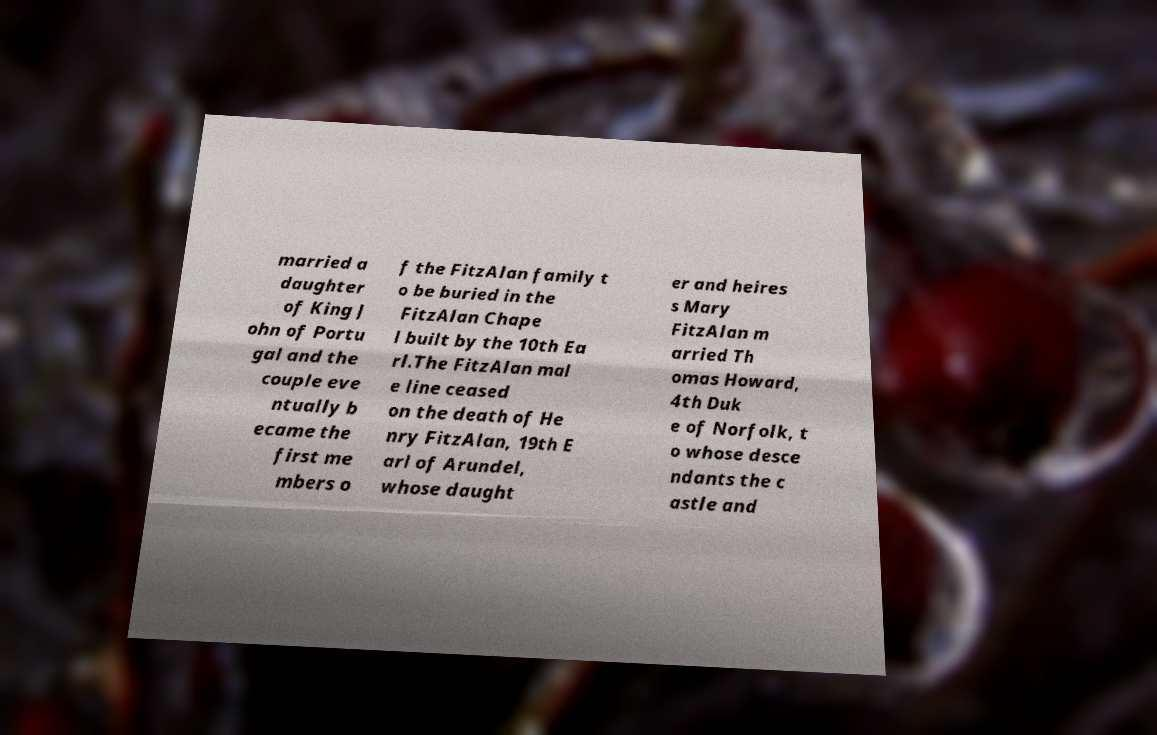What messages or text are displayed in this image? I need them in a readable, typed format. married a daughter of King J ohn of Portu gal and the couple eve ntually b ecame the first me mbers o f the FitzAlan family t o be buried in the FitzAlan Chape l built by the 10th Ea rl.The FitzAlan mal e line ceased on the death of He nry FitzAlan, 19th E arl of Arundel, whose daught er and heires s Mary FitzAlan m arried Th omas Howard, 4th Duk e of Norfolk, t o whose desce ndants the c astle and 